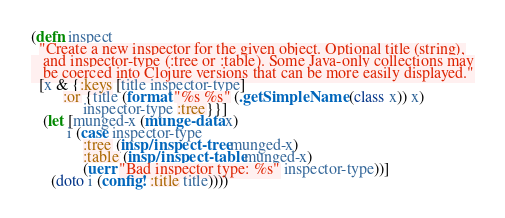<code> <loc_0><loc_0><loc_500><loc_500><_Clojure_>(defn inspect 
  "Create a new inspector for the given object. Optional title (string),
   and inspector-type (:tree or :table). Some Java-only collections may
   be coerced into Clojure versions that can be more easily displayed."
  [x & {:keys [title inspector-type] 
        :or {title (format "%s %s" (.getSimpleName (class x)) x)
             inspector-type :tree}}]
   (let [munged-x (munge-data x)
         i (case inspector-type 
             :tree (insp/inspect-tree munged-x) 
             :table (insp/inspect-table munged-x)
             (uerr "Bad inspector type: %s" inspector-type))]
     (doto i (config! :title title))))


</code> 